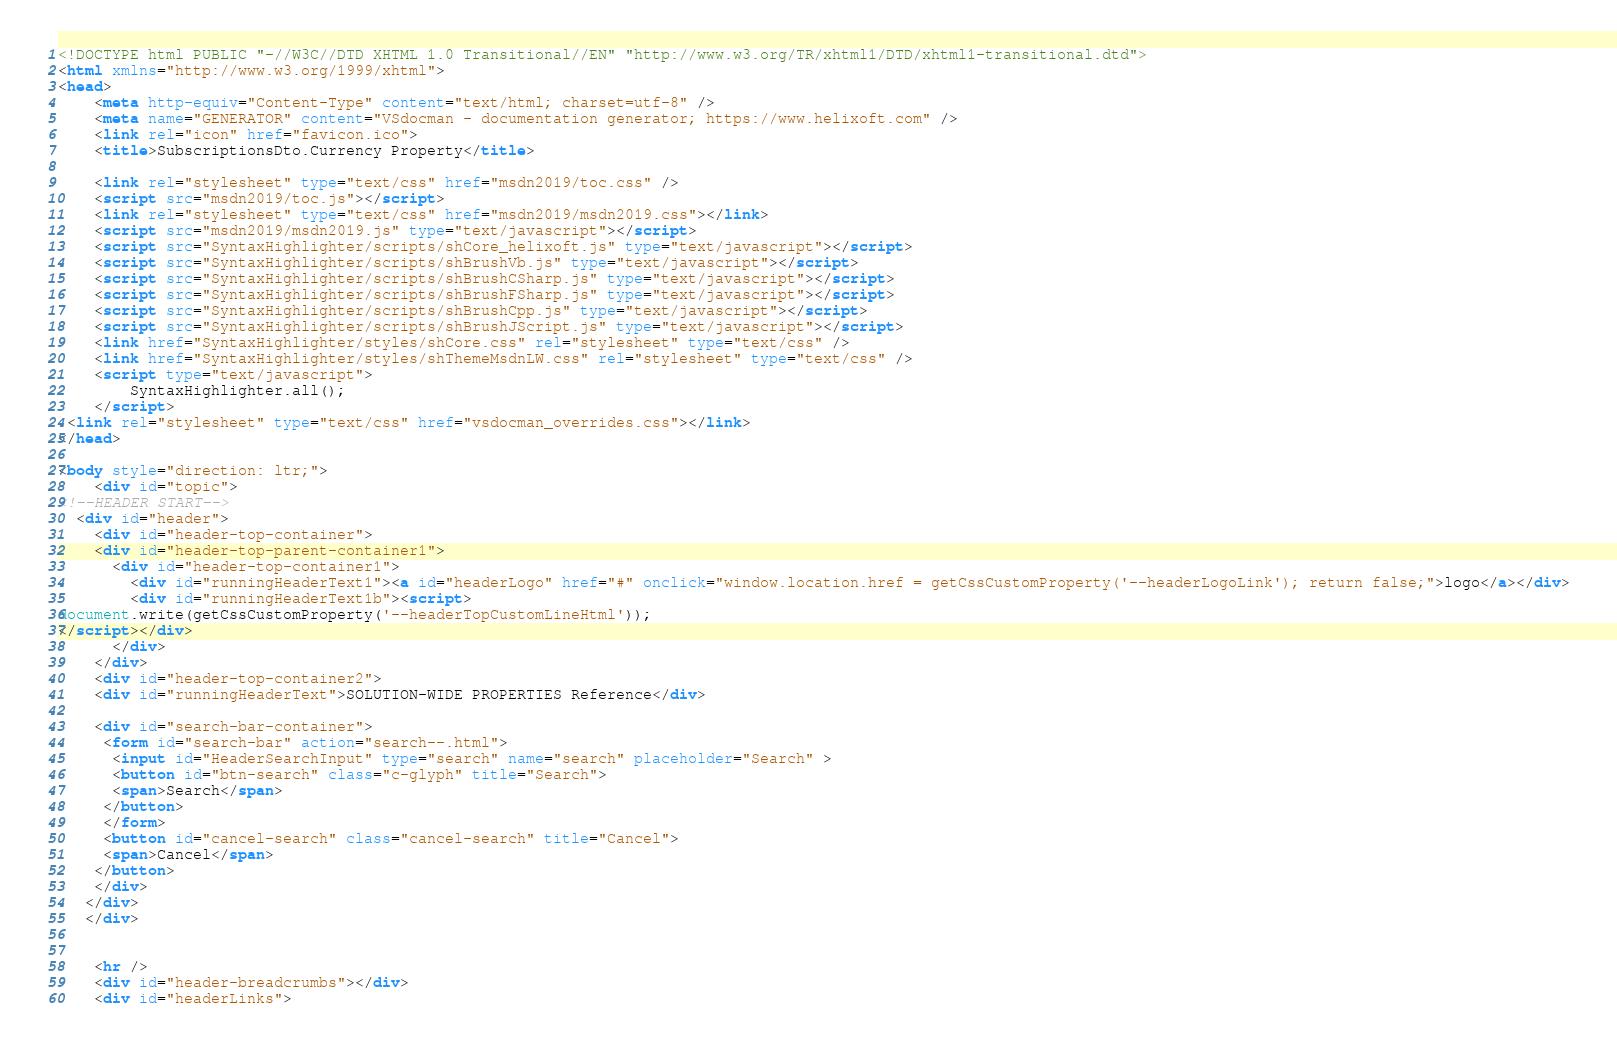<code> <loc_0><loc_0><loc_500><loc_500><_HTML_><!DOCTYPE html PUBLIC "-//W3C//DTD XHTML 1.0 Transitional//EN" "http://www.w3.org/TR/xhtml1/DTD/xhtml1-transitional.dtd">
<html xmlns="http://www.w3.org/1999/xhtml">
<head>
	<meta http-equiv="Content-Type" content="text/html; charset=utf-8" />
	<meta name="GENERATOR" content="VSdocman - documentation generator; https://www.helixoft.com" />
	<link rel="icon" href="favicon.ico">
	<title>SubscriptionsDto.Currency Property</title>

	<link rel="stylesheet" type="text/css" href="msdn2019/toc.css" />
	<script src="msdn2019/toc.js"></script>
	<link rel="stylesheet" type="text/css" href="msdn2019/msdn2019.css"></link>
	<script src="msdn2019/msdn2019.js" type="text/javascript"></script>
	<script src="SyntaxHighlighter/scripts/shCore_helixoft.js" type="text/javascript"></script>
	<script src="SyntaxHighlighter/scripts/shBrushVb.js" type="text/javascript"></script>
	<script src="SyntaxHighlighter/scripts/shBrushCSharp.js" type="text/javascript"></script>
	<script src="SyntaxHighlighter/scripts/shBrushFSharp.js" type="text/javascript"></script>
	<script src="SyntaxHighlighter/scripts/shBrushCpp.js" type="text/javascript"></script>
	<script src="SyntaxHighlighter/scripts/shBrushJScript.js" type="text/javascript"></script>
	<link href="SyntaxHighlighter/styles/shCore.css" rel="stylesheet" type="text/css" />
	<link href="SyntaxHighlighter/styles/shThemeMsdnLW.css" rel="stylesheet" type="text/css" />
	<script type="text/javascript">
		SyntaxHighlighter.all();
	</script>
 <link rel="stylesheet" type="text/css" href="vsdocman_overrides.css"></link> 
</head>

<body style="direction: ltr;">
	<div id="topic">
<!--HEADER START-->
  <div id="header">
  	<div id="header-top-container">	
	<div id="header-top-parent-container1">
	  <div id="header-top-container1">
	    <div id="runningHeaderText1"><a id="headerLogo" href="#" onclick="window.location.href = getCssCustomProperty('--headerLogoLink'); return false;">logo</a></div>
	    <div id="runningHeaderText1b"><script>
document.write(getCssCustomProperty('--headerTopCustomLineHtml'));
</script></div>
	  </div>
	</div>
  	<div id="header-top-container2">
    <div id="runningHeaderText">SOLUTION-WIDE PROPERTIES Reference</div>
   
    <div id="search-bar-container">
     <form id="search-bar" action="search--.html">
      <input id="HeaderSearchInput" type="search" name="search" placeholder="Search" >
      <button id="btn-search" class="c-glyph" title="Search">
      <span>Search</span>
     </button>
     </form>
     <button id="cancel-search" class="cancel-search" title="Cancel">
     <span>Cancel</span>
    </button>
    </div>
   </div>
   </div>

  	
  	<hr />
	<div id="header-breadcrumbs"></div>
	<div id="headerLinks"></code> 